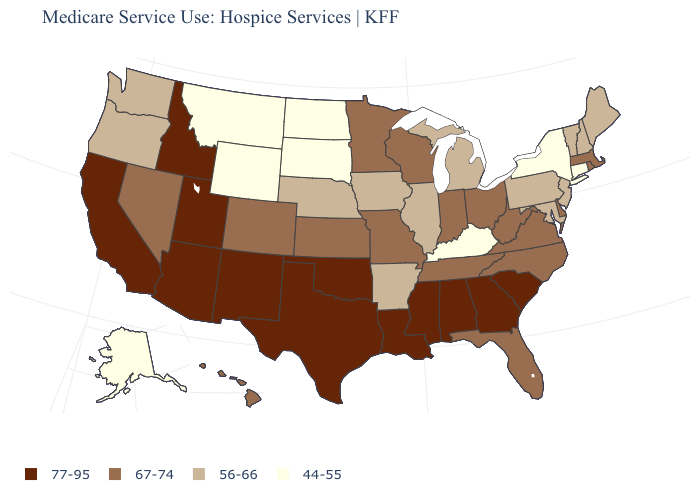Does Wisconsin have the highest value in the MidWest?
Short answer required. Yes. Name the states that have a value in the range 56-66?
Quick response, please. Arkansas, Illinois, Iowa, Maine, Maryland, Michigan, Nebraska, New Hampshire, New Jersey, Oregon, Pennsylvania, Vermont, Washington. Among the states that border Utah , which have the lowest value?
Short answer required. Wyoming. What is the value of Kentucky?
Give a very brief answer. 44-55. Does Kentucky have the lowest value in the South?
Give a very brief answer. Yes. Name the states that have a value in the range 77-95?
Short answer required. Alabama, Arizona, California, Georgia, Idaho, Louisiana, Mississippi, New Mexico, Oklahoma, South Carolina, Texas, Utah. What is the value of Arkansas?
Short answer required. 56-66. Among the states that border Montana , which have the highest value?
Keep it brief. Idaho. Among the states that border Iowa , which have the lowest value?
Quick response, please. South Dakota. Among the states that border Texas , does New Mexico have the lowest value?
Short answer required. No. What is the value of Virginia?
Quick response, please. 67-74. What is the value of Massachusetts?
Be succinct. 67-74. Does Wisconsin have the highest value in the MidWest?
Be succinct. Yes. What is the value of Alabama?
Be succinct. 77-95. Does Delaware have the lowest value in the South?
Quick response, please. No. 